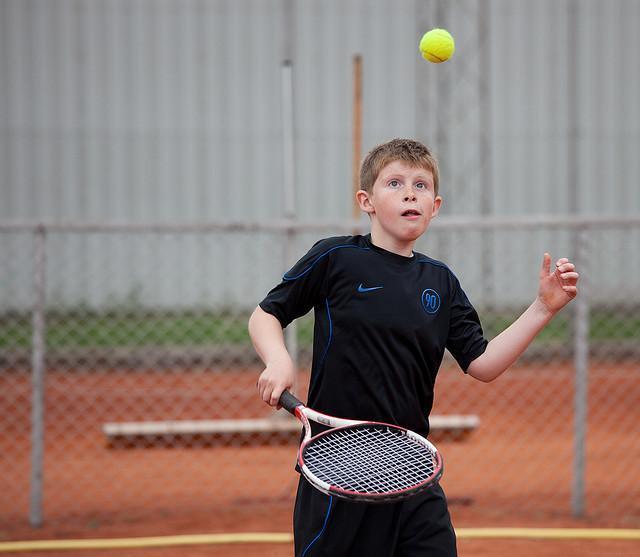How many dogs are running on the beach?
Give a very brief answer. 0. 